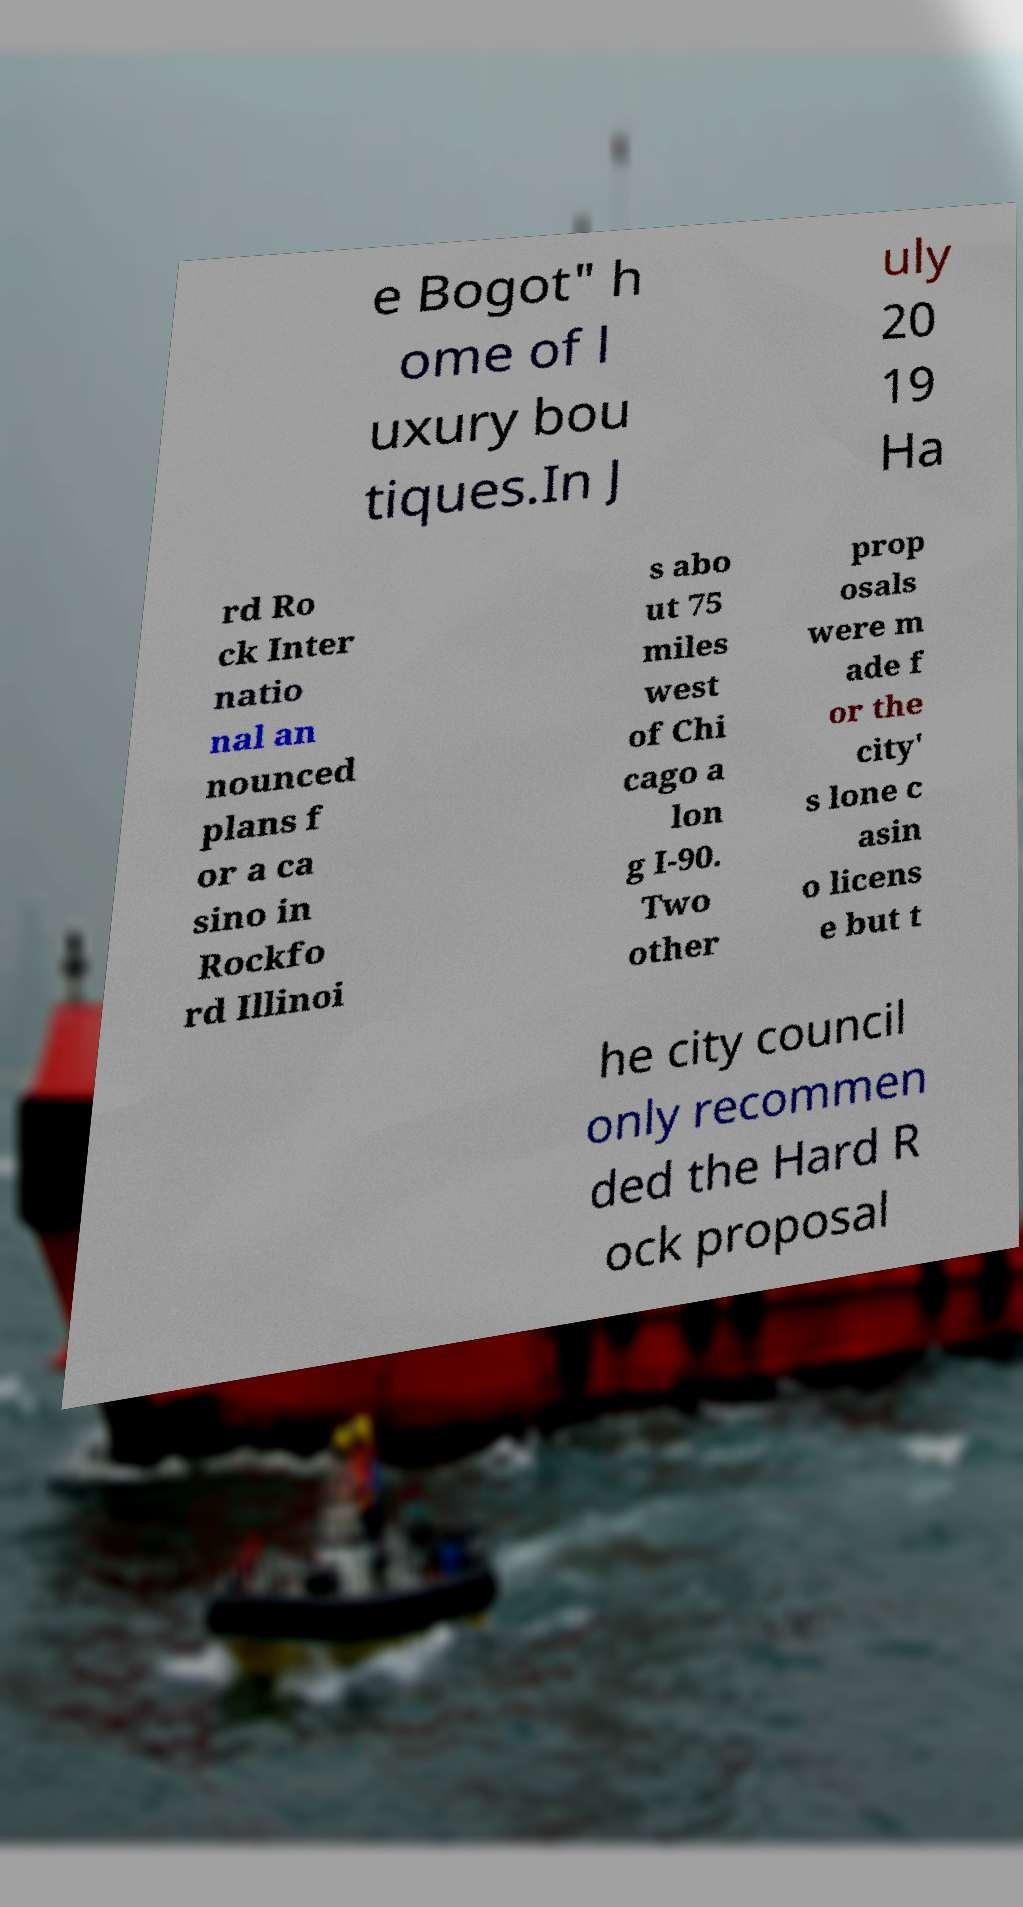Can you read and provide the text displayed in the image?This photo seems to have some interesting text. Can you extract and type it out for me? e Bogot" h ome of l uxury bou tiques.In J uly 20 19 Ha rd Ro ck Inter natio nal an nounced plans f or a ca sino in Rockfo rd Illinoi s abo ut 75 miles west of Chi cago a lon g I-90. Two other prop osals were m ade f or the city' s lone c asin o licens e but t he city council only recommen ded the Hard R ock proposal 